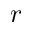<formula> <loc_0><loc_0><loc_500><loc_500>r</formula> 